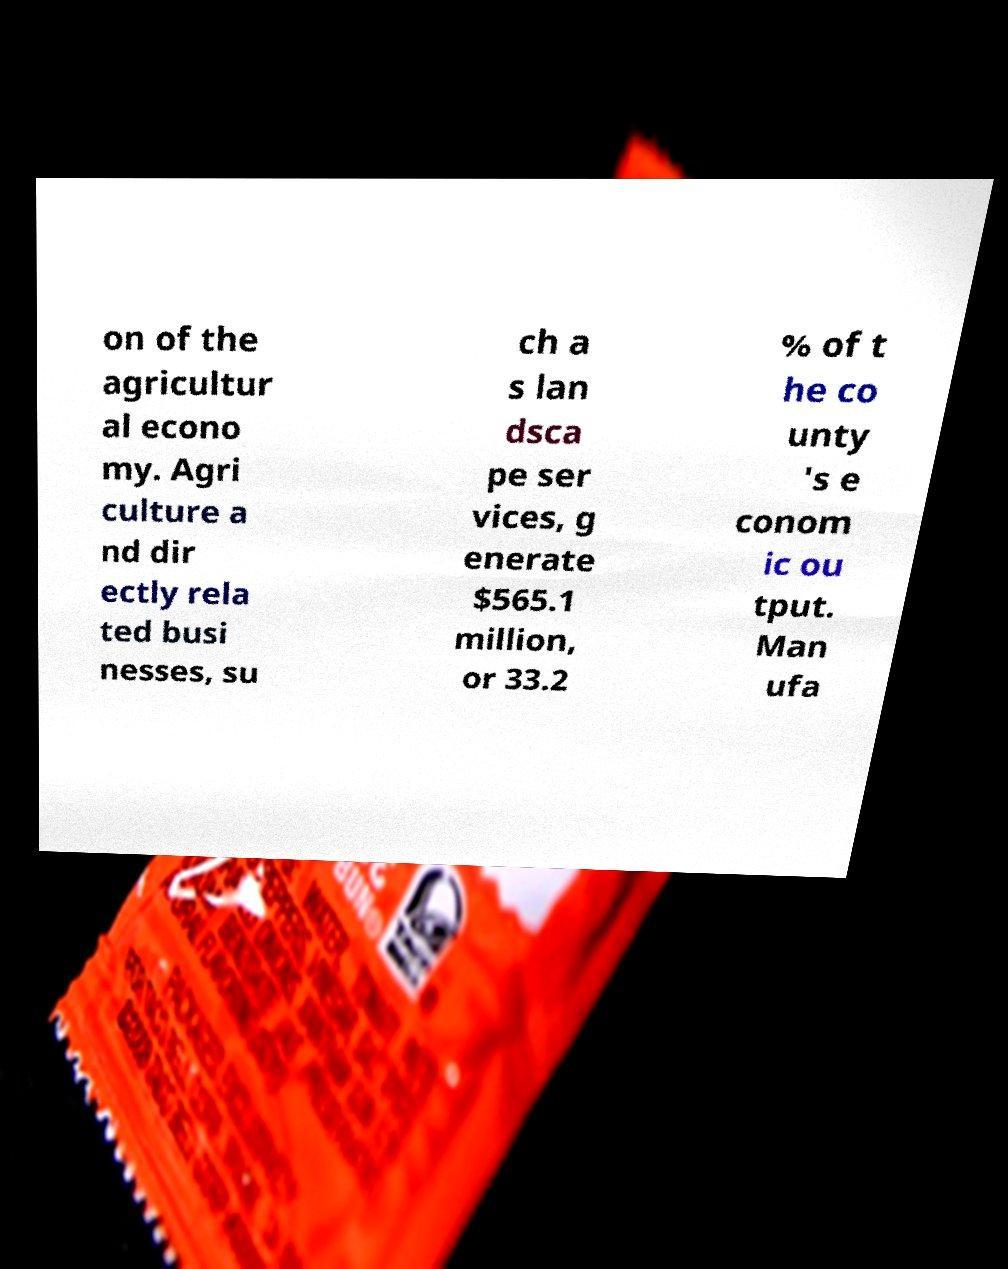Can you read and provide the text displayed in the image?This photo seems to have some interesting text. Can you extract and type it out for me? on of the agricultur al econo my. Agri culture a nd dir ectly rela ted busi nesses, su ch a s lan dsca pe ser vices, g enerate $565.1 million, or 33.2 % of t he co unty 's e conom ic ou tput. Man ufa 